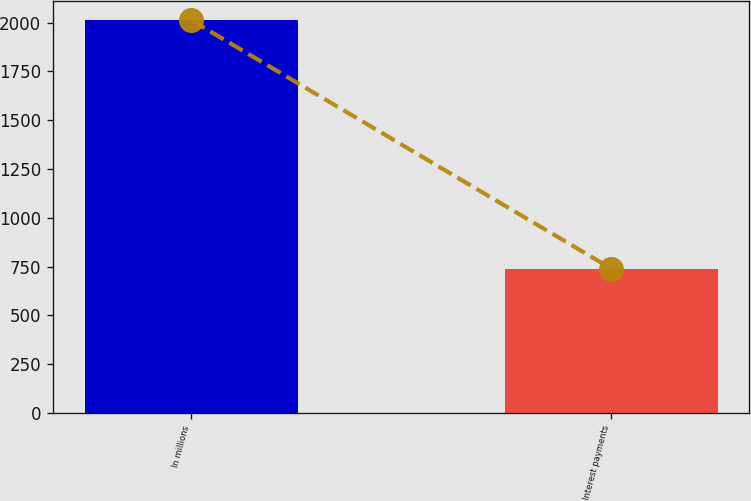<chart> <loc_0><loc_0><loc_500><loc_500><bar_chart><fcel>In millions<fcel>Interest payments<nl><fcel>2012<fcel>740<nl></chart> 